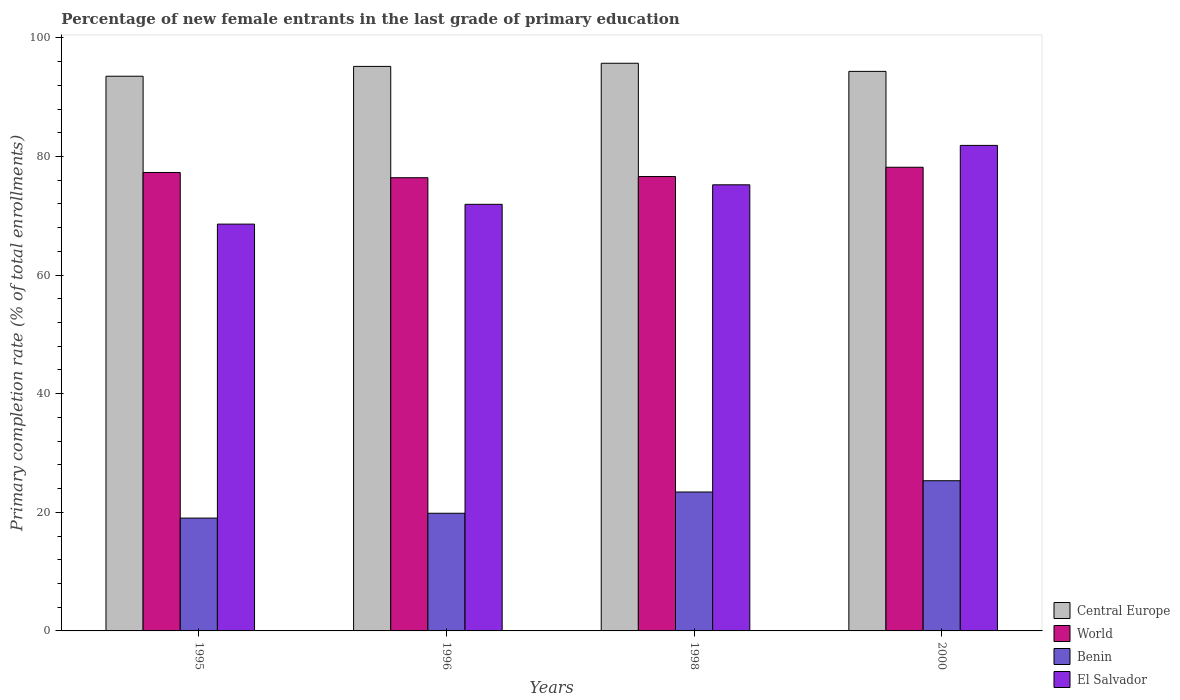How many different coloured bars are there?
Offer a terse response. 4. Are the number of bars per tick equal to the number of legend labels?
Offer a terse response. Yes. How many bars are there on the 1st tick from the right?
Offer a terse response. 4. What is the label of the 2nd group of bars from the left?
Provide a succinct answer. 1996. In how many cases, is the number of bars for a given year not equal to the number of legend labels?
Make the answer very short. 0. What is the percentage of new female entrants in El Salvador in 1995?
Ensure brevity in your answer.  68.59. Across all years, what is the maximum percentage of new female entrants in World?
Your answer should be compact. 78.18. Across all years, what is the minimum percentage of new female entrants in Central Europe?
Your answer should be very brief. 93.53. In which year was the percentage of new female entrants in Central Europe maximum?
Provide a short and direct response. 1998. In which year was the percentage of new female entrants in Central Europe minimum?
Your response must be concise. 1995. What is the total percentage of new female entrants in El Salvador in the graph?
Offer a very short reply. 297.61. What is the difference between the percentage of new female entrants in Central Europe in 1996 and that in 2000?
Your answer should be very brief. 0.84. What is the difference between the percentage of new female entrants in Benin in 1998 and the percentage of new female entrants in Central Europe in 1996?
Keep it short and to the point. -71.77. What is the average percentage of new female entrants in World per year?
Offer a very short reply. 77.13. In the year 1995, what is the difference between the percentage of new female entrants in Central Europe and percentage of new female entrants in World?
Provide a short and direct response. 16.23. In how many years, is the percentage of new female entrants in El Salvador greater than 80 %?
Offer a very short reply. 1. What is the ratio of the percentage of new female entrants in El Salvador in 1998 to that in 2000?
Offer a very short reply. 0.92. Is the percentage of new female entrants in World in 1996 less than that in 2000?
Provide a short and direct response. Yes. Is the difference between the percentage of new female entrants in Central Europe in 1995 and 1996 greater than the difference between the percentage of new female entrants in World in 1995 and 1996?
Ensure brevity in your answer.  No. What is the difference between the highest and the second highest percentage of new female entrants in World?
Provide a succinct answer. 0.88. What is the difference between the highest and the lowest percentage of new female entrants in El Salvador?
Give a very brief answer. 13.27. In how many years, is the percentage of new female entrants in Benin greater than the average percentage of new female entrants in Benin taken over all years?
Your answer should be compact. 2. Is it the case that in every year, the sum of the percentage of new female entrants in Benin and percentage of new female entrants in Central Europe is greater than the sum of percentage of new female entrants in El Salvador and percentage of new female entrants in World?
Your answer should be compact. No. What does the 4th bar from the left in 1998 represents?
Your answer should be very brief. El Salvador. What does the 2nd bar from the right in 2000 represents?
Provide a succinct answer. Benin. How many bars are there?
Keep it short and to the point. 16. How many years are there in the graph?
Ensure brevity in your answer.  4. Where does the legend appear in the graph?
Your answer should be compact. Bottom right. How many legend labels are there?
Your answer should be compact. 4. What is the title of the graph?
Keep it short and to the point. Percentage of new female entrants in the last grade of primary education. What is the label or title of the X-axis?
Offer a very short reply. Years. What is the label or title of the Y-axis?
Your answer should be compact. Primary completion rate (% of total enrollments). What is the Primary completion rate (% of total enrollments) of Central Europe in 1995?
Make the answer very short. 93.53. What is the Primary completion rate (% of total enrollments) in World in 1995?
Your response must be concise. 77.3. What is the Primary completion rate (% of total enrollments) in Benin in 1995?
Offer a terse response. 19.02. What is the Primary completion rate (% of total enrollments) of El Salvador in 1995?
Keep it short and to the point. 68.59. What is the Primary completion rate (% of total enrollments) in Central Europe in 1996?
Make the answer very short. 95.19. What is the Primary completion rate (% of total enrollments) in World in 1996?
Keep it short and to the point. 76.42. What is the Primary completion rate (% of total enrollments) of Benin in 1996?
Keep it short and to the point. 19.84. What is the Primary completion rate (% of total enrollments) of El Salvador in 1996?
Your answer should be compact. 71.93. What is the Primary completion rate (% of total enrollments) of Central Europe in 1998?
Your answer should be compact. 95.72. What is the Primary completion rate (% of total enrollments) in World in 1998?
Make the answer very short. 76.62. What is the Primary completion rate (% of total enrollments) in Benin in 1998?
Your response must be concise. 23.42. What is the Primary completion rate (% of total enrollments) of El Salvador in 1998?
Your answer should be very brief. 75.22. What is the Primary completion rate (% of total enrollments) in Central Europe in 2000?
Make the answer very short. 94.35. What is the Primary completion rate (% of total enrollments) of World in 2000?
Keep it short and to the point. 78.18. What is the Primary completion rate (% of total enrollments) in Benin in 2000?
Provide a succinct answer. 25.33. What is the Primary completion rate (% of total enrollments) in El Salvador in 2000?
Make the answer very short. 81.87. Across all years, what is the maximum Primary completion rate (% of total enrollments) of Central Europe?
Offer a terse response. 95.72. Across all years, what is the maximum Primary completion rate (% of total enrollments) of World?
Your answer should be very brief. 78.18. Across all years, what is the maximum Primary completion rate (% of total enrollments) in Benin?
Keep it short and to the point. 25.33. Across all years, what is the maximum Primary completion rate (% of total enrollments) of El Salvador?
Keep it short and to the point. 81.87. Across all years, what is the minimum Primary completion rate (% of total enrollments) of Central Europe?
Your answer should be compact. 93.53. Across all years, what is the minimum Primary completion rate (% of total enrollments) of World?
Give a very brief answer. 76.42. Across all years, what is the minimum Primary completion rate (% of total enrollments) in Benin?
Your answer should be compact. 19.02. Across all years, what is the minimum Primary completion rate (% of total enrollments) of El Salvador?
Provide a succinct answer. 68.59. What is the total Primary completion rate (% of total enrollments) of Central Europe in the graph?
Offer a terse response. 378.78. What is the total Primary completion rate (% of total enrollments) of World in the graph?
Keep it short and to the point. 308.51. What is the total Primary completion rate (% of total enrollments) of Benin in the graph?
Your answer should be very brief. 87.61. What is the total Primary completion rate (% of total enrollments) of El Salvador in the graph?
Ensure brevity in your answer.  297.61. What is the difference between the Primary completion rate (% of total enrollments) of Central Europe in 1995 and that in 1996?
Provide a short and direct response. -1.66. What is the difference between the Primary completion rate (% of total enrollments) of World in 1995 and that in 1996?
Your answer should be very brief. 0.89. What is the difference between the Primary completion rate (% of total enrollments) in Benin in 1995 and that in 1996?
Your answer should be very brief. -0.81. What is the difference between the Primary completion rate (% of total enrollments) of El Salvador in 1995 and that in 1996?
Your response must be concise. -3.34. What is the difference between the Primary completion rate (% of total enrollments) of Central Europe in 1995 and that in 1998?
Your response must be concise. -2.19. What is the difference between the Primary completion rate (% of total enrollments) in World in 1995 and that in 1998?
Offer a very short reply. 0.69. What is the difference between the Primary completion rate (% of total enrollments) of Benin in 1995 and that in 1998?
Ensure brevity in your answer.  -4.4. What is the difference between the Primary completion rate (% of total enrollments) of El Salvador in 1995 and that in 1998?
Keep it short and to the point. -6.63. What is the difference between the Primary completion rate (% of total enrollments) in Central Europe in 1995 and that in 2000?
Keep it short and to the point. -0.82. What is the difference between the Primary completion rate (% of total enrollments) of World in 1995 and that in 2000?
Your answer should be very brief. -0.88. What is the difference between the Primary completion rate (% of total enrollments) in Benin in 1995 and that in 2000?
Ensure brevity in your answer.  -6.3. What is the difference between the Primary completion rate (% of total enrollments) in El Salvador in 1995 and that in 2000?
Provide a short and direct response. -13.27. What is the difference between the Primary completion rate (% of total enrollments) of Central Europe in 1996 and that in 1998?
Provide a succinct answer. -0.53. What is the difference between the Primary completion rate (% of total enrollments) in World in 1996 and that in 1998?
Give a very brief answer. -0.2. What is the difference between the Primary completion rate (% of total enrollments) of Benin in 1996 and that in 1998?
Ensure brevity in your answer.  -3.58. What is the difference between the Primary completion rate (% of total enrollments) in El Salvador in 1996 and that in 1998?
Provide a short and direct response. -3.29. What is the difference between the Primary completion rate (% of total enrollments) in Central Europe in 1996 and that in 2000?
Your answer should be compact. 0.84. What is the difference between the Primary completion rate (% of total enrollments) in World in 1996 and that in 2000?
Ensure brevity in your answer.  -1.76. What is the difference between the Primary completion rate (% of total enrollments) in Benin in 1996 and that in 2000?
Ensure brevity in your answer.  -5.49. What is the difference between the Primary completion rate (% of total enrollments) in El Salvador in 1996 and that in 2000?
Make the answer very short. -9.94. What is the difference between the Primary completion rate (% of total enrollments) in Central Europe in 1998 and that in 2000?
Give a very brief answer. 1.37. What is the difference between the Primary completion rate (% of total enrollments) in World in 1998 and that in 2000?
Make the answer very short. -1.56. What is the difference between the Primary completion rate (% of total enrollments) of Benin in 1998 and that in 2000?
Make the answer very short. -1.9. What is the difference between the Primary completion rate (% of total enrollments) of El Salvador in 1998 and that in 2000?
Make the answer very short. -6.64. What is the difference between the Primary completion rate (% of total enrollments) in Central Europe in 1995 and the Primary completion rate (% of total enrollments) in World in 1996?
Provide a succinct answer. 17.11. What is the difference between the Primary completion rate (% of total enrollments) of Central Europe in 1995 and the Primary completion rate (% of total enrollments) of Benin in 1996?
Make the answer very short. 73.69. What is the difference between the Primary completion rate (% of total enrollments) of Central Europe in 1995 and the Primary completion rate (% of total enrollments) of El Salvador in 1996?
Give a very brief answer. 21.6. What is the difference between the Primary completion rate (% of total enrollments) of World in 1995 and the Primary completion rate (% of total enrollments) of Benin in 1996?
Offer a very short reply. 57.46. What is the difference between the Primary completion rate (% of total enrollments) of World in 1995 and the Primary completion rate (% of total enrollments) of El Salvador in 1996?
Your answer should be compact. 5.37. What is the difference between the Primary completion rate (% of total enrollments) of Benin in 1995 and the Primary completion rate (% of total enrollments) of El Salvador in 1996?
Offer a very short reply. -52.91. What is the difference between the Primary completion rate (% of total enrollments) of Central Europe in 1995 and the Primary completion rate (% of total enrollments) of World in 1998?
Your response must be concise. 16.91. What is the difference between the Primary completion rate (% of total enrollments) in Central Europe in 1995 and the Primary completion rate (% of total enrollments) in Benin in 1998?
Your response must be concise. 70.11. What is the difference between the Primary completion rate (% of total enrollments) of Central Europe in 1995 and the Primary completion rate (% of total enrollments) of El Salvador in 1998?
Your answer should be very brief. 18.31. What is the difference between the Primary completion rate (% of total enrollments) in World in 1995 and the Primary completion rate (% of total enrollments) in Benin in 1998?
Your answer should be compact. 53.88. What is the difference between the Primary completion rate (% of total enrollments) in World in 1995 and the Primary completion rate (% of total enrollments) in El Salvador in 1998?
Your answer should be very brief. 2.08. What is the difference between the Primary completion rate (% of total enrollments) in Benin in 1995 and the Primary completion rate (% of total enrollments) in El Salvador in 1998?
Keep it short and to the point. -56.2. What is the difference between the Primary completion rate (% of total enrollments) in Central Europe in 1995 and the Primary completion rate (% of total enrollments) in World in 2000?
Your response must be concise. 15.35. What is the difference between the Primary completion rate (% of total enrollments) in Central Europe in 1995 and the Primary completion rate (% of total enrollments) in Benin in 2000?
Your answer should be compact. 68.2. What is the difference between the Primary completion rate (% of total enrollments) in Central Europe in 1995 and the Primary completion rate (% of total enrollments) in El Salvador in 2000?
Provide a succinct answer. 11.66. What is the difference between the Primary completion rate (% of total enrollments) of World in 1995 and the Primary completion rate (% of total enrollments) of Benin in 2000?
Offer a very short reply. 51.98. What is the difference between the Primary completion rate (% of total enrollments) in World in 1995 and the Primary completion rate (% of total enrollments) in El Salvador in 2000?
Offer a terse response. -4.56. What is the difference between the Primary completion rate (% of total enrollments) of Benin in 1995 and the Primary completion rate (% of total enrollments) of El Salvador in 2000?
Ensure brevity in your answer.  -62.84. What is the difference between the Primary completion rate (% of total enrollments) of Central Europe in 1996 and the Primary completion rate (% of total enrollments) of World in 1998?
Provide a short and direct response. 18.57. What is the difference between the Primary completion rate (% of total enrollments) in Central Europe in 1996 and the Primary completion rate (% of total enrollments) in Benin in 1998?
Provide a short and direct response. 71.77. What is the difference between the Primary completion rate (% of total enrollments) of Central Europe in 1996 and the Primary completion rate (% of total enrollments) of El Salvador in 1998?
Offer a terse response. 19.97. What is the difference between the Primary completion rate (% of total enrollments) in World in 1996 and the Primary completion rate (% of total enrollments) in Benin in 1998?
Make the answer very short. 52.99. What is the difference between the Primary completion rate (% of total enrollments) of World in 1996 and the Primary completion rate (% of total enrollments) of El Salvador in 1998?
Keep it short and to the point. 1.19. What is the difference between the Primary completion rate (% of total enrollments) of Benin in 1996 and the Primary completion rate (% of total enrollments) of El Salvador in 1998?
Your response must be concise. -55.38. What is the difference between the Primary completion rate (% of total enrollments) of Central Europe in 1996 and the Primary completion rate (% of total enrollments) of World in 2000?
Provide a succinct answer. 17.01. What is the difference between the Primary completion rate (% of total enrollments) in Central Europe in 1996 and the Primary completion rate (% of total enrollments) in Benin in 2000?
Your answer should be compact. 69.86. What is the difference between the Primary completion rate (% of total enrollments) of Central Europe in 1996 and the Primary completion rate (% of total enrollments) of El Salvador in 2000?
Provide a succinct answer. 13.32. What is the difference between the Primary completion rate (% of total enrollments) of World in 1996 and the Primary completion rate (% of total enrollments) of Benin in 2000?
Your response must be concise. 51.09. What is the difference between the Primary completion rate (% of total enrollments) in World in 1996 and the Primary completion rate (% of total enrollments) in El Salvador in 2000?
Offer a terse response. -5.45. What is the difference between the Primary completion rate (% of total enrollments) in Benin in 1996 and the Primary completion rate (% of total enrollments) in El Salvador in 2000?
Offer a very short reply. -62.03. What is the difference between the Primary completion rate (% of total enrollments) in Central Europe in 1998 and the Primary completion rate (% of total enrollments) in World in 2000?
Offer a terse response. 17.54. What is the difference between the Primary completion rate (% of total enrollments) of Central Europe in 1998 and the Primary completion rate (% of total enrollments) of Benin in 2000?
Provide a succinct answer. 70.39. What is the difference between the Primary completion rate (% of total enrollments) in Central Europe in 1998 and the Primary completion rate (% of total enrollments) in El Salvador in 2000?
Offer a very short reply. 13.85. What is the difference between the Primary completion rate (% of total enrollments) of World in 1998 and the Primary completion rate (% of total enrollments) of Benin in 2000?
Your answer should be compact. 51.29. What is the difference between the Primary completion rate (% of total enrollments) of World in 1998 and the Primary completion rate (% of total enrollments) of El Salvador in 2000?
Keep it short and to the point. -5.25. What is the difference between the Primary completion rate (% of total enrollments) of Benin in 1998 and the Primary completion rate (% of total enrollments) of El Salvador in 2000?
Your answer should be compact. -58.45. What is the average Primary completion rate (% of total enrollments) of Central Europe per year?
Your answer should be very brief. 94.7. What is the average Primary completion rate (% of total enrollments) of World per year?
Your response must be concise. 77.13. What is the average Primary completion rate (% of total enrollments) in Benin per year?
Keep it short and to the point. 21.9. What is the average Primary completion rate (% of total enrollments) in El Salvador per year?
Provide a short and direct response. 74.4. In the year 1995, what is the difference between the Primary completion rate (% of total enrollments) in Central Europe and Primary completion rate (% of total enrollments) in World?
Your answer should be compact. 16.23. In the year 1995, what is the difference between the Primary completion rate (% of total enrollments) of Central Europe and Primary completion rate (% of total enrollments) of Benin?
Offer a very short reply. 74.51. In the year 1995, what is the difference between the Primary completion rate (% of total enrollments) in Central Europe and Primary completion rate (% of total enrollments) in El Salvador?
Provide a succinct answer. 24.94. In the year 1995, what is the difference between the Primary completion rate (% of total enrollments) in World and Primary completion rate (% of total enrollments) in Benin?
Make the answer very short. 58.28. In the year 1995, what is the difference between the Primary completion rate (% of total enrollments) in World and Primary completion rate (% of total enrollments) in El Salvador?
Provide a short and direct response. 8.71. In the year 1995, what is the difference between the Primary completion rate (% of total enrollments) in Benin and Primary completion rate (% of total enrollments) in El Salvador?
Keep it short and to the point. -49.57. In the year 1996, what is the difference between the Primary completion rate (% of total enrollments) in Central Europe and Primary completion rate (% of total enrollments) in World?
Provide a succinct answer. 18.77. In the year 1996, what is the difference between the Primary completion rate (% of total enrollments) in Central Europe and Primary completion rate (% of total enrollments) in Benin?
Provide a succinct answer. 75.35. In the year 1996, what is the difference between the Primary completion rate (% of total enrollments) in Central Europe and Primary completion rate (% of total enrollments) in El Salvador?
Make the answer very short. 23.26. In the year 1996, what is the difference between the Primary completion rate (% of total enrollments) in World and Primary completion rate (% of total enrollments) in Benin?
Provide a short and direct response. 56.58. In the year 1996, what is the difference between the Primary completion rate (% of total enrollments) in World and Primary completion rate (% of total enrollments) in El Salvador?
Your answer should be very brief. 4.49. In the year 1996, what is the difference between the Primary completion rate (% of total enrollments) in Benin and Primary completion rate (% of total enrollments) in El Salvador?
Offer a very short reply. -52.09. In the year 1998, what is the difference between the Primary completion rate (% of total enrollments) in Central Europe and Primary completion rate (% of total enrollments) in World?
Your response must be concise. 19.1. In the year 1998, what is the difference between the Primary completion rate (% of total enrollments) of Central Europe and Primary completion rate (% of total enrollments) of Benin?
Make the answer very short. 72.3. In the year 1998, what is the difference between the Primary completion rate (% of total enrollments) of Central Europe and Primary completion rate (% of total enrollments) of El Salvador?
Provide a short and direct response. 20.49. In the year 1998, what is the difference between the Primary completion rate (% of total enrollments) in World and Primary completion rate (% of total enrollments) in Benin?
Ensure brevity in your answer.  53.19. In the year 1998, what is the difference between the Primary completion rate (% of total enrollments) in World and Primary completion rate (% of total enrollments) in El Salvador?
Your response must be concise. 1.39. In the year 1998, what is the difference between the Primary completion rate (% of total enrollments) of Benin and Primary completion rate (% of total enrollments) of El Salvador?
Provide a succinct answer. -51.8. In the year 2000, what is the difference between the Primary completion rate (% of total enrollments) in Central Europe and Primary completion rate (% of total enrollments) in World?
Give a very brief answer. 16.17. In the year 2000, what is the difference between the Primary completion rate (% of total enrollments) in Central Europe and Primary completion rate (% of total enrollments) in Benin?
Offer a very short reply. 69.02. In the year 2000, what is the difference between the Primary completion rate (% of total enrollments) in Central Europe and Primary completion rate (% of total enrollments) in El Salvador?
Give a very brief answer. 12.48. In the year 2000, what is the difference between the Primary completion rate (% of total enrollments) in World and Primary completion rate (% of total enrollments) in Benin?
Ensure brevity in your answer.  52.85. In the year 2000, what is the difference between the Primary completion rate (% of total enrollments) in World and Primary completion rate (% of total enrollments) in El Salvador?
Give a very brief answer. -3.69. In the year 2000, what is the difference between the Primary completion rate (% of total enrollments) of Benin and Primary completion rate (% of total enrollments) of El Salvador?
Your response must be concise. -56.54. What is the ratio of the Primary completion rate (% of total enrollments) in Central Europe in 1995 to that in 1996?
Provide a short and direct response. 0.98. What is the ratio of the Primary completion rate (% of total enrollments) of World in 1995 to that in 1996?
Offer a very short reply. 1.01. What is the ratio of the Primary completion rate (% of total enrollments) in El Salvador in 1995 to that in 1996?
Offer a terse response. 0.95. What is the ratio of the Primary completion rate (% of total enrollments) of Central Europe in 1995 to that in 1998?
Make the answer very short. 0.98. What is the ratio of the Primary completion rate (% of total enrollments) of Benin in 1995 to that in 1998?
Provide a succinct answer. 0.81. What is the ratio of the Primary completion rate (% of total enrollments) of El Salvador in 1995 to that in 1998?
Offer a very short reply. 0.91. What is the ratio of the Primary completion rate (% of total enrollments) of Benin in 1995 to that in 2000?
Provide a succinct answer. 0.75. What is the ratio of the Primary completion rate (% of total enrollments) in El Salvador in 1995 to that in 2000?
Offer a terse response. 0.84. What is the ratio of the Primary completion rate (% of total enrollments) of Central Europe in 1996 to that in 1998?
Keep it short and to the point. 0.99. What is the ratio of the Primary completion rate (% of total enrollments) in World in 1996 to that in 1998?
Give a very brief answer. 1. What is the ratio of the Primary completion rate (% of total enrollments) in Benin in 1996 to that in 1998?
Offer a terse response. 0.85. What is the ratio of the Primary completion rate (% of total enrollments) in El Salvador in 1996 to that in 1998?
Offer a terse response. 0.96. What is the ratio of the Primary completion rate (% of total enrollments) in Central Europe in 1996 to that in 2000?
Provide a succinct answer. 1.01. What is the ratio of the Primary completion rate (% of total enrollments) of World in 1996 to that in 2000?
Offer a very short reply. 0.98. What is the ratio of the Primary completion rate (% of total enrollments) of Benin in 1996 to that in 2000?
Your response must be concise. 0.78. What is the ratio of the Primary completion rate (% of total enrollments) of El Salvador in 1996 to that in 2000?
Give a very brief answer. 0.88. What is the ratio of the Primary completion rate (% of total enrollments) in Central Europe in 1998 to that in 2000?
Provide a succinct answer. 1.01. What is the ratio of the Primary completion rate (% of total enrollments) in World in 1998 to that in 2000?
Make the answer very short. 0.98. What is the ratio of the Primary completion rate (% of total enrollments) in Benin in 1998 to that in 2000?
Your answer should be compact. 0.92. What is the ratio of the Primary completion rate (% of total enrollments) of El Salvador in 1998 to that in 2000?
Your answer should be compact. 0.92. What is the difference between the highest and the second highest Primary completion rate (% of total enrollments) of Central Europe?
Make the answer very short. 0.53. What is the difference between the highest and the second highest Primary completion rate (% of total enrollments) of World?
Offer a terse response. 0.88. What is the difference between the highest and the second highest Primary completion rate (% of total enrollments) in Benin?
Offer a terse response. 1.9. What is the difference between the highest and the second highest Primary completion rate (% of total enrollments) in El Salvador?
Ensure brevity in your answer.  6.64. What is the difference between the highest and the lowest Primary completion rate (% of total enrollments) of Central Europe?
Provide a succinct answer. 2.19. What is the difference between the highest and the lowest Primary completion rate (% of total enrollments) in World?
Make the answer very short. 1.76. What is the difference between the highest and the lowest Primary completion rate (% of total enrollments) in Benin?
Provide a succinct answer. 6.3. What is the difference between the highest and the lowest Primary completion rate (% of total enrollments) of El Salvador?
Your response must be concise. 13.27. 